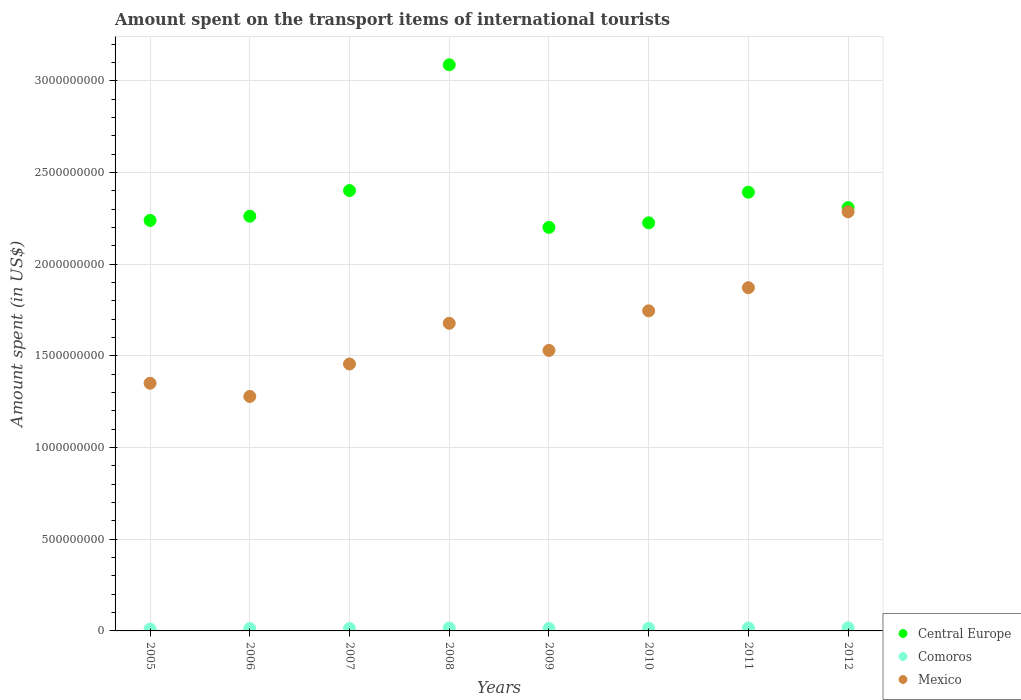How many different coloured dotlines are there?
Provide a succinct answer. 3. What is the amount spent on the transport items of international tourists in Central Europe in 2007?
Provide a succinct answer. 2.40e+09. Across all years, what is the maximum amount spent on the transport items of international tourists in Comoros?
Keep it short and to the point. 1.70e+07. Across all years, what is the minimum amount spent on the transport items of international tourists in Central Europe?
Your answer should be compact. 2.20e+09. In which year was the amount spent on the transport items of international tourists in Comoros minimum?
Keep it short and to the point. 2005. What is the total amount spent on the transport items of international tourists in Central Europe in the graph?
Make the answer very short. 1.91e+1. What is the difference between the amount spent on the transport items of international tourists in Mexico in 2005 and that in 2011?
Offer a very short reply. -5.21e+08. What is the difference between the amount spent on the transport items of international tourists in Mexico in 2010 and the amount spent on the transport items of international tourists in Central Europe in 2007?
Your response must be concise. -6.56e+08. What is the average amount spent on the transport items of international tourists in Central Europe per year?
Give a very brief answer. 2.39e+09. In the year 2012, what is the difference between the amount spent on the transport items of international tourists in Central Europe and amount spent on the transport items of international tourists in Mexico?
Offer a terse response. 2.30e+07. What is the ratio of the amount spent on the transport items of international tourists in Central Europe in 2009 to that in 2012?
Provide a succinct answer. 0.95. Is the amount spent on the transport items of international tourists in Central Europe in 2005 less than that in 2008?
Make the answer very short. Yes. Is the difference between the amount spent on the transport items of international tourists in Central Europe in 2007 and 2012 greater than the difference between the amount spent on the transport items of international tourists in Mexico in 2007 and 2012?
Your response must be concise. Yes. What is the difference between the highest and the second highest amount spent on the transport items of international tourists in Comoros?
Offer a very short reply. 1.00e+06. What is the difference between the highest and the lowest amount spent on the transport items of international tourists in Central Europe?
Provide a short and direct response. 8.87e+08. Is it the case that in every year, the sum of the amount spent on the transport items of international tourists in Mexico and amount spent on the transport items of international tourists in Comoros  is greater than the amount spent on the transport items of international tourists in Central Europe?
Provide a short and direct response. No. Is the amount spent on the transport items of international tourists in Comoros strictly greater than the amount spent on the transport items of international tourists in Central Europe over the years?
Your answer should be compact. No. How many dotlines are there?
Your response must be concise. 3. How many years are there in the graph?
Give a very brief answer. 8. Are the values on the major ticks of Y-axis written in scientific E-notation?
Give a very brief answer. No. Does the graph contain any zero values?
Offer a very short reply. No. Where does the legend appear in the graph?
Offer a terse response. Bottom right. How many legend labels are there?
Give a very brief answer. 3. What is the title of the graph?
Offer a very short reply. Amount spent on the transport items of international tourists. What is the label or title of the X-axis?
Your answer should be compact. Years. What is the label or title of the Y-axis?
Your answer should be compact. Amount spent (in US$). What is the Amount spent (in US$) in Central Europe in 2005?
Your answer should be compact. 2.24e+09. What is the Amount spent (in US$) of Mexico in 2005?
Your response must be concise. 1.35e+09. What is the Amount spent (in US$) in Central Europe in 2006?
Offer a terse response. 2.26e+09. What is the Amount spent (in US$) of Comoros in 2006?
Make the answer very short. 1.30e+07. What is the Amount spent (in US$) in Mexico in 2006?
Ensure brevity in your answer.  1.28e+09. What is the Amount spent (in US$) in Central Europe in 2007?
Your answer should be very brief. 2.40e+09. What is the Amount spent (in US$) of Comoros in 2007?
Offer a very short reply. 1.30e+07. What is the Amount spent (in US$) of Mexico in 2007?
Provide a succinct answer. 1.46e+09. What is the Amount spent (in US$) of Central Europe in 2008?
Ensure brevity in your answer.  3.09e+09. What is the Amount spent (in US$) of Comoros in 2008?
Make the answer very short. 1.60e+07. What is the Amount spent (in US$) in Mexico in 2008?
Ensure brevity in your answer.  1.68e+09. What is the Amount spent (in US$) in Central Europe in 2009?
Give a very brief answer. 2.20e+09. What is the Amount spent (in US$) in Comoros in 2009?
Offer a very short reply. 1.30e+07. What is the Amount spent (in US$) in Mexico in 2009?
Give a very brief answer. 1.53e+09. What is the Amount spent (in US$) in Central Europe in 2010?
Provide a short and direct response. 2.23e+09. What is the Amount spent (in US$) of Comoros in 2010?
Offer a terse response. 1.40e+07. What is the Amount spent (in US$) of Mexico in 2010?
Ensure brevity in your answer.  1.75e+09. What is the Amount spent (in US$) of Central Europe in 2011?
Provide a succinct answer. 2.39e+09. What is the Amount spent (in US$) of Comoros in 2011?
Your answer should be very brief. 1.60e+07. What is the Amount spent (in US$) in Mexico in 2011?
Give a very brief answer. 1.87e+09. What is the Amount spent (in US$) in Central Europe in 2012?
Ensure brevity in your answer.  2.31e+09. What is the Amount spent (in US$) in Comoros in 2012?
Your answer should be very brief. 1.70e+07. What is the Amount spent (in US$) in Mexico in 2012?
Your answer should be compact. 2.29e+09. Across all years, what is the maximum Amount spent (in US$) of Central Europe?
Your response must be concise. 3.09e+09. Across all years, what is the maximum Amount spent (in US$) of Comoros?
Your answer should be very brief. 1.70e+07. Across all years, what is the maximum Amount spent (in US$) in Mexico?
Provide a short and direct response. 2.29e+09. Across all years, what is the minimum Amount spent (in US$) of Central Europe?
Give a very brief answer. 2.20e+09. Across all years, what is the minimum Amount spent (in US$) of Mexico?
Offer a very short reply. 1.28e+09. What is the total Amount spent (in US$) of Central Europe in the graph?
Your answer should be very brief. 1.91e+1. What is the total Amount spent (in US$) of Comoros in the graph?
Make the answer very short. 1.12e+08. What is the total Amount spent (in US$) in Mexico in the graph?
Keep it short and to the point. 1.32e+1. What is the difference between the Amount spent (in US$) in Central Europe in 2005 and that in 2006?
Offer a terse response. -2.30e+07. What is the difference between the Amount spent (in US$) in Mexico in 2005 and that in 2006?
Your response must be concise. 7.20e+07. What is the difference between the Amount spent (in US$) in Central Europe in 2005 and that in 2007?
Provide a succinct answer. -1.63e+08. What is the difference between the Amount spent (in US$) of Mexico in 2005 and that in 2007?
Your answer should be compact. -1.05e+08. What is the difference between the Amount spent (in US$) of Central Europe in 2005 and that in 2008?
Provide a succinct answer. -8.49e+08. What is the difference between the Amount spent (in US$) of Comoros in 2005 and that in 2008?
Your response must be concise. -6.00e+06. What is the difference between the Amount spent (in US$) in Mexico in 2005 and that in 2008?
Give a very brief answer. -3.27e+08. What is the difference between the Amount spent (in US$) of Central Europe in 2005 and that in 2009?
Offer a very short reply. 3.80e+07. What is the difference between the Amount spent (in US$) in Comoros in 2005 and that in 2009?
Your answer should be very brief. -3.00e+06. What is the difference between the Amount spent (in US$) in Mexico in 2005 and that in 2009?
Offer a very short reply. -1.79e+08. What is the difference between the Amount spent (in US$) of Central Europe in 2005 and that in 2010?
Give a very brief answer. 1.30e+07. What is the difference between the Amount spent (in US$) in Mexico in 2005 and that in 2010?
Offer a very short reply. -3.95e+08. What is the difference between the Amount spent (in US$) in Central Europe in 2005 and that in 2011?
Your answer should be compact. -1.54e+08. What is the difference between the Amount spent (in US$) of Comoros in 2005 and that in 2011?
Ensure brevity in your answer.  -6.00e+06. What is the difference between the Amount spent (in US$) in Mexico in 2005 and that in 2011?
Give a very brief answer. -5.21e+08. What is the difference between the Amount spent (in US$) of Central Europe in 2005 and that in 2012?
Your response must be concise. -7.00e+07. What is the difference between the Amount spent (in US$) in Comoros in 2005 and that in 2012?
Give a very brief answer. -7.00e+06. What is the difference between the Amount spent (in US$) in Mexico in 2005 and that in 2012?
Provide a succinct answer. -9.35e+08. What is the difference between the Amount spent (in US$) of Central Europe in 2006 and that in 2007?
Your response must be concise. -1.40e+08. What is the difference between the Amount spent (in US$) of Mexico in 2006 and that in 2007?
Your response must be concise. -1.77e+08. What is the difference between the Amount spent (in US$) in Central Europe in 2006 and that in 2008?
Ensure brevity in your answer.  -8.26e+08. What is the difference between the Amount spent (in US$) of Comoros in 2006 and that in 2008?
Your answer should be very brief. -3.00e+06. What is the difference between the Amount spent (in US$) of Mexico in 2006 and that in 2008?
Provide a succinct answer. -3.99e+08. What is the difference between the Amount spent (in US$) of Central Europe in 2006 and that in 2009?
Your answer should be compact. 6.10e+07. What is the difference between the Amount spent (in US$) in Mexico in 2006 and that in 2009?
Offer a terse response. -2.51e+08. What is the difference between the Amount spent (in US$) of Central Europe in 2006 and that in 2010?
Provide a short and direct response. 3.60e+07. What is the difference between the Amount spent (in US$) in Comoros in 2006 and that in 2010?
Offer a terse response. -1.00e+06. What is the difference between the Amount spent (in US$) of Mexico in 2006 and that in 2010?
Keep it short and to the point. -4.67e+08. What is the difference between the Amount spent (in US$) in Central Europe in 2006 and that in 2011?
Provide a short and direct response. -1.31e+08. What is the difference between the Amount spent (in US$) in Mexico in 2006 and that in 2011?
Offer a terse response. -5.93e+08. What is the difference between the Amount spent (in US$) in Central Europe in 2006 and that in 2012?
Keep it short and to the point. -4.70e+07. What is the difference between the Amount spent (in US$) of Comoros in 2006 and that in 2012?
Your answer should be very brief. -4.00e+06. What is the difference between the Amount spent (in US$) in Mexico in 2006 and that in 2012?
Provide a short and direct response. -1.01e+09. What is the difference between the Amount spent (in US$) of Central Europe in 2007 and that in 2008?
Your answer should be very brief. -6.86e+08. What is the difference between the Amount spent (in US$) of Mexico in 2007 and that in 2008?
Give a very brief answer. -2.22e+08. What is the difference between the Amount spent (in US$) in Central Europe in 2007 and that in 2009?
Your answer should be very brief. 2.01e+08. What is the difference between the Amount spent (in US$) in Mexico in 2007 and that in 2009?
Ensure brevity in your answer.  -7.40e+07. What is the difference between the Amount spent (in US$) in Central Europe in 2007 and that in 2010?
Offer a very short reply. 1.76e+08. What is the difference between the Amount spent (in US$) in Comoros in 2007 and that in 2010?
Your answer should be compact. -1.00e+06. What is the difference between the Amount spent (in US$) of Mexico in 2007 and that in 2010?
Give a very brief answer. -2.90e+08. What is the difference between the Amount spent (in US$) in Central Europe in 2007 and that in 2011?
Your answer should be compact. 9.00e+06. What is the difference between the Amount spent (in US$) in Mexico in 2007 and that in 2011?
Your answer should be compact. -4.16e+08. What is the difference between the Amount spent (in US$) in Central Europe in 2007 and that in 2012?
Ensure brevity in your answer.  9.30e+07. What is the difference between the Amount spent (in US$) of Comoros in 2007 and that in 2012?
Your answer should be compact. -4.00e+06. What is the difference between the Amount spent (in US$) of Mexico in 2007 and that in 2012?
Offer a terse response. -8.30e+08. What is the difference between the Amount spent (in US$) of Central Europe in 2008 and that in 2009?
Your answer should be very brief. 8.87e+08. What is the difference between the Amount spent (in US$) in Mexico in 2008 and that in 2009?
Keep it short and to the point. 1.48e+08. What is the difference between the Amount spent (in US$) in Central Europe in 2008 and that in 2010?
Your response must be concise. 8.62e+08. What is the difference between the Amount spent (in US$) in Comoros in 2008 and that in 2010?
Offer a very short reply. 2.00e+06. What is the difference between the Amount spent (in US$) of Mexico in 2008 and that in 2010?
Make the answer very short. -6.80e+07. What is the difference between the Amount spent (in US$) of Central Europe in 2008 and that in 2011?
Keep it short and to the point. 6.95e+08. What is the difference between the Amount spent (in US$) of Comoros in 2008 and that in 2011?
Offer a very short reply. 0. What is the difference between the Amount spent (in US$) of Mexico in 2008 and that in 2011?
Give a very brief answer. -1.94e+08. What is the difference between the Amount spent (in US$) in Central Europe in 2008 and that in 2012?
Give a very brief answer. 7.79e+08. What is the difference between the Amount spent (in US$) of Comoros in 2008 and that in 2012?
Ensure brevity in your answer.  -1.00e+06. What is the difference between the Amount spent (in US$) in Mexico in 2008 and that in 2012?
Your answer should be very brief. -6.08e+08. What is the difference between the Amount spent (in US$) in Central Europe in 2009 and that in 2010?
Your answer should be very brief. -2.50e+07. What is the difference between the Amount spent (in US$) of Mexico in 2009 and that in 2010?
Your answer should be compact. -2.16e+08. What is the difference between the Amount spent (in US$) in Central Europe in 2009 and that in 2011?
Your answer should be compact. -1.92e+08. What is the difference between the Amount spent (in US$) in Mexico in 2009 and that in 2011?
Make the answer very short. -3.42e+08. What is the difference between the Amount spent (in US$) of Central Europe in 2009 and that in 2012?
Your answer should be very brief. -1.08e+08. What is the difference between the Amount spent (in US$) in Mexico in 2009 and that in 2012?
Offer a terse response. -7.56e+08. What is the difference between the Amount spent (in US$) of Central Europe in 2010 and that in 2011?
Make the answer very short. -1.67e+08. What is the difference between the Amount spent (in US$) of Mexico in 2010 and that in 2011?
Provide a succinct answer. -1.26e+08. What is the difference between the Amount spent (in US$) in Central Europe in 2010 and that in 2012?
Provide a succinct answer. -8.30e+07. What is the difference between the Amount spent (in US$) in Mexico in 2010 and that in 2012?
Offer a terse response. -5.40e+08. What is the difference between the Amount spent (in US$) of Central Europe in 2011 and that in 2012?
Provide a succinct answer. 8.40e+07. What is the difference between the Amount spent (in US$) in Mexico in 2011 and that in 2012?
Make the answer very short. -4.14e+08. What is the difference between the Amount spent (in US$) in Central Europe in 2005 and the Amount spent (in US$) in Comoros in 2006?
Provide a short and direct response. 2.23e+09. What is the difference between the Amount spent (in US$) in Central Europe in 2005 and the Amount spent (in US$) in Mexico in 2006?
Offer a very short reply. 9.60e+08. What is the difference between the Amount spent (in US$) of Comoros in 2005 and the Amount spent (in US$) of Mexico in 2006?
Your answer should be compact. -1.27e+09. What is the difference between the Amount spent (in US$) in Central Europe in 2005 and the Amount spent (in US$) in Comoros in 2007?
Give a very brief answer. 2.23e+09. What is the difference between the Amount spent (in US$) of Central Europe in 2005 and the Amount spent (in US$) of Mexico in 2007?
Your answer should be compact. 7.83e+08. What is the difference between the Amount spent (in US$) in Comoros in 2005 and the Amount spent (in US$) in Mexico in 2007?
Give a very brief answer. -1.45e+09. What is the difference between the Amount spent (in US$) in Central Europe in 2005 and the Amount spent (in US$) in Comoros in 2008?
Offer a very short reply. 2.22e+09. What is the difference between the Amount spent (in US$) in Central Europe in 2005 and the Amount spent (in US$) in Mexico in 2008?
Give a very brief answer. 5.61e+08. What is the difference between the Amount spent (in US$) of Comoros in 2005 and the Amount spent (in US$) of Mexico in 2008?
Your response must be concise. -1.67e+09. What is the difference between the Amount spent (in US$) of Central Europe in 2005 and the Amount spent (in US$) of Comoros in 2009?
Offer a very short reply. 2.23e+09. What is the difference between the Amount spent (in US$) of Central Europe in 2005 and the Amount spent (in US$) of Mexico in 2009?
Offer a terse response. 7.09e+08. What is the difference between the Amount spent (in US$) in Comoros in 2005 and the Amount spent (in US$) in Mexico in 2009?
Your answer should be compact. -1.52e+09. What is the difference between the Amount spent (in US$) in Central Europe in 2005 and the Amount spent (in US$) in Comoros in 2010?
Ensure brevity in your answer.  2.22e+09. What is the difference between the Amount spent (in US$) of Central Europe in 2005 and the Amount spent (in US$) of Mexico in 2010?
Your answer should be very brief. 4.93e+08. What is the difference between the Amount spent (in US$) of Comoros in 2005 and the Amount spent (in US$) of Mexico in 2010?
Your response must be concise. -1.74e+09. What is the difference between the Amount spent (in US$) in Central Europe in 2005 and the Amount spent (in US$) in Comoros in 2011?
Your answer should be compact. 2.22e+09. What is the difference between the Amount spent (in US$) in Central Europe in 2005 and the Amount spent (in US$) in Mexico in 2011?
Give a very brief answer. 3.67e+08. What is the difference between the Amount spent (in US$) in Comoros in 2005 and the Amount spent (in US$) in Mexico in 2011?
Provide a succinct answer. -1.86e+09. What is the difference between the Amount spent (in US$) in Central Europe in 2005 and the Amount spent (in US$) in Comoros in 2012?
Offer a very short reply. 2.22e+09. What is the difference between the Amount spent (in US$) in Central Europe in 2005 and the Amount spent (in US$) in Mexico in 2012?
Your answer should be very brief. -4.70e+07. What is the difference between the Amount spent (in US$) in Comoros in 2005 and the Amount spent (in US$) in Mexico in 2012?
Make the answer very short. -2.28e+09. What is the difference between the Amount spent (in US$) in Central Europe in 2006 and the Amount spent (in US$) in Comoros in 2007?
Give a very brief answer. 2.25e+09. What is the difference between the Amount spent (in US$) in Central Europe in 2006 and the Amount spent (in US$) in Mexico in 2007?
Your answer should be very brief. 8.06e+08. What is the difference between the Amount spent (in US$) in Comoros in 2006 and the Amount spent (in US$) in Mexico in 2007?
Your answer should be compact. -1.44e+09. What is the difference between the Amount spent (in US$) in Central Europe in 2006 and the Amount spent (in US$) in Comoros in 2008?
Keep it short and to the point. 2.25e+09. What is the difference between the Amount spent (in US$) in Central Europe in 2006 and the Amount spent (in US$) in Mexico in 2008?
Offer a very short reply. 5.84e+08. What is the difference between the Amount spent (in US$) in Comoros in 2006 and the Amount spent (in US$) in Mexico in 2008?
Give a very brief answer. -1.66e+09. What is the difference between the Amount spent (in US$) of Central Europe in 2006 and the Amount spent (in US$) of Comoros in 2009?
Provide a succinct answer. 2.25e+09. What is the difference between the Amount spent (in US$) of Central Europe in 2006 and the Amount spent (in US$) of Mexico in 2009?
Your response must be concise. 7.32e+08. What is the difference between the Amount spent (in US$) in Comoros in 2006 and the Amount spent (in US$) in Mexico in 2009?
Offer a terse response. -1.52e+09. What is the difference between the Amount spent (in US$) in Central Europe in 2006 and the Amount spent (in US$) in Comoros in 2010?
Provide a short and direct response. 2.25e+09. What is the difference between the Amount spent (in US$) of Central Europe in 2006 and the Amount spent (in US$) of Mexico in 2010?
Make the answer very short. 5.16e+08. What is the difference between the Amount spent (in US$) of Comoros in 2006 and the Amount spent (in US$) of Mexico in 2010?
Provide a succinct answer. -1.73e+09. What is the difference between the Amount spent (in US$) of Central Europe in 2006 and the Amount spent (in US$) of Comoros in 2011?
Ensure brevity in your answer.  2.25e+09. What is the difference between the Amount spent (in US$) in Central Europe in 2006 and the Amount spent (in US$) in Mexico in 2011?
Provide a short and direct response. 3.90e+08. What is the difference between the Amount spent (in US$) in Comoros in 2006 and the Amount spent (in US$) in Mexico in 2011?
Give a very brief answer. -1.86e+09. What is the difference between the Amount spent (in US$) of Central Europe in 2006 and the Amount spent (in US$) of Comoros in 2012?
Your answer should be compact. 2.24e+09. What is the difference between the Amount spent (in US$) of Central Europe in 2006 and the Amount spent (in US$) of Mexico in 2012?
Offer a very short reply. -2.40e+07. What is the difference between the Amount spent (in US$) in Comoros in 2006 and the Amount spent (in US$) in Mexico in 2012?
Offer a very short reply. -2.27e+09. What is the difference between the Amount spent (in US$) in Central Europe in 2007 and the Amount spent (in US$) in Comoros in 2008?
Keep it short and to the point. 2.39e+09. What is the difference between the Amount spent (in US$) of Central Europe in 2007 and the Amount spent (in US$) of Mexico in 2008?
Provide a short and direct response. 7.24e+08. What is the difference between the Amount spent (in US$) in Comoros in 2007 and the Amount spent (in US$) in Mexico in 2008?
Offer a very short reply. -1.66e+09. What is the difference between the Amount spent (in US$) of Central Europe in 2007 and the Amount spent (in US$) of Comoros in 2009?
Make the answer very short. 2.39e+09. What is the difference between the Amount spent (in US$) of Central Europe in 2007 and the Amount spent (in US$) of Mexico in 2009?
Provide a short and direct response. 8.72e+08. What is the difference between the Amount spent (in US$) in Comoros in 2007 and the Amount spent (in US$) in Mexico in 2009?
Your response must be concise. -1.52e+09. What is the difference between the Amount spent (in US$) in Central Europe in 2007 and the Amount spent (in US$) in Comoros in 2010?
Provide a succinct answer. 2.39e+09. What is the difference between the Amount spent (in US$) of Central Europe in 2007 and the Amount spent (in US$) of Mexico in 2010?
Ensure brevity in your answer.  6.56e+08. What is the difference between the Amount spent (in US$) in Comoros in 2007 and the Amount spent (in US$) in Mexico in 2010?
Ensure brevity in your answer.  -1.73e+09. What is the difference between the Amount spent (in US$) of Central Europe in 2007 and the Amount spent (in US$) of Comoros in 2011?
Provide a succinct answer. 2.39e+09. What is the difference between the Amount spent (in US$) of Central Europe in 2007 and the Amount spent (in US$) of Mexico in 2011?
Keep it short and to the point. 5.30e+08. What is the difference between the Amount spent (in US$) in Comoros in 2007 and the Amount spent (in US$) in Mexico in 2011?
Give a very brief answer. -1.86e+09. What is the difference between the Amount spent (in US$) of Central Europe in 2007 and the Amount spent (in US$) of Comoros in 2012?
Your answer should be very brief. 2.38e+09. What is the difference between the Amount spent (in US$) in Central Europe in 2007 and the Amount spent (in US$) in Mexico in 2012?
Ensure brevity in your answer.  1.16e+08. What is the difference between the Amount spent (in US$) of Comoros in 2007 and the Amount spent (in US$) of Mexico in 2012?
Your answer should be very brief. -2.27e+09. What is the difference between the Amount spent (in US$) in Central Europe in 2008 and the Amount spent (in US$) in Comoros in 2009?
Your answer should be compact. 3.08e+09. What is the difference between the Amount spent (in US$) of Central Europe in 2008 and the Amount spent (in US$) of Mexico in 2009?
Your answer should be compact. 1.56e+09. What is the difference between the Amount spent (in US$) of Comoros in 2008 and the Amount spent (in US$) of Mexico in 2009?
Give a very brief answer. -1.51e+09. What is the difference between the Amount spent (in US$) of Central Europe in 2008 and the Amount spent (in US$) of Comoros in 2010?
Offer a very short reply. 3.07e+09. What is the difference between the Amount spent (in US$) of Central Europe in 2008 and the Amount spent (in US$) of Mexico in 2010?
Ensure brevity in your answer.  1.34e+09. What is the difference between the Amount spent (in US$) in Comoros in 2008 and the Amount spent (in US$) in Mexico in 2010?
Your answer should be compact. -1.73e+09. What is the difference between the Amount spent (in US$) in Central Europe in 2008 and the Amount spent (in US$) in Comoros in 2011?
Your answer should be compact. 3.07e+09. What is the difference between the Amount spent (in US$) of Central Europe in 2008 and the Amount spent (in US$) of Mexico in 2011?
Provide a succinct answer. 1.22e+09. What is the difference between the Amount spent (in US$) in Comoros in 2008 and the Amount spent (in US$) in Mexico in 2011?
Keep it short and to the point. -1.86e+09. What is the difference between the Amount spent (in US$) of Central Europe in 2008 and the Amount spent (in US$) of Comoros in 2012?
Provide a succinct answer. 3.07e+09. What is the difference between the Amount spent (in US$) in Central Europe in 2008 and the Amount spent (in US$) in Mexico in 2012?
Give a very brief answer. 8.02e+08. What is the difference between the Amount spent (in US$) in Comoros in 2008 and the Amount spent (in US$) in Mexico in 2012?
Keep it short and to the point. -2.27e+09. What is the difference between the Amount spent (in US$) of Central Europe in 2009 and the Amount spent (in US$) of Comoros in 2010?
Keep it short and to the point. 2.19e+09. What is the difference between the Amount spent (in US$) in Central Europe in 2009 and the Amount spent (in US$) in Mexico in 2010?
Offer a very short reply. 4.55e+08. What is the difference between the Amount spent (in US$) in Comoros in 2009 and the Amount spent (in US$) in Mexico in 2010?
Ensure brevity in your answer.  -1.73e+09. What is the difference between the Amount spent (in US$) in Central Europe in 2009 and the Amount spent (in US$) in Comoros in 2011?
Your response must be concise. 2.18e+09. What is the difference between the Amount spent (in US$) in Central Europe in 2009 and the Amount spent (in US$) in Mexico in 2011?
Offer a terse response. 3.29e+08. What is the difference between the Amount spent (in US$) of Comoros in 2009 and the Amount spent (in US$) of Mexico in 2011?
Your answer should be compact. -1.86e+09. What is the difference between the Amount spent (in US$) of Central Europe in 2009 and the Amount spent (in US$) of Comoros in 2012?
Your response must be concise. 2.18e+09. What is the difference between the Amount spent (in US$) in Central Europe in 2009 and the Amount spent (in US$) in Mexico in 2012?
Your answer should be compact. -8.50e+07. What is the difference between the Amount spent (in US$) of Comoros in 2009 and the Amount spent (in US$) of Mexico in 2012?
Make the answer very short. -2.27e+09. What is the difference between the Amount spent (in US$) of Central Europe in 2010 and the Amount spent (in US$) of Comoros in 2011?
Give a very brief answer. 2.21e+09. What is the difference between the Amount spent (in US$) in Central Europe in 2010 and the Amount spent (in US$) in Mexico in 2011?
Give a very brief answer. 3.54e+08. What is the difference between the Amount spent (in US$) of Comoros in 2010 and the Amount spent (in US$) of Mexico in 2011?
Provide a short and direct response. -1.86e+09. What is the difference between the Amount spent (in US$) in Central Europe in 2010 and the Amount spent (in US$) in Comoros in 2012?
Ensure brevity in your answer.  2.21e+09. What is the difference between the Amount spent (in US$) in Central Europe in 2010 and the Amount spent (in US$) in Mexico in 2012?
Provide a succinct answer. -6.00e+07. What is the difference between the Amount spent (in US$) in Comoros in 2010 and the Amount spent (in US$) in Mexico in 2012?
Provide a short and direct response. -2.27e+09. What is the difference between the Amount spent (in US$) of Central Europe in 2011 and the Amount spent (in US$) of Comoros in 2012?
Your answer should be very brief. 2.38e+09. What is the difference between the Amount spent (in US$) of Central Europe in 2011 and the Amount spent (in US$) of Mexico in 2012?
Your answer should be very brief. 1.07e+08. What is the difference between the Amount spent (in US$) in Comoros in 2011 and the Amount spent (in US$) in Mexico in 2012?
Provide a short and direct response. -2.27e+09. What is the average Amount spent (in US$) of Central Europe per year?
Offer a very short reply. 2.39e+09. What is the average Amount spent (in US$) in Comoros per year?
Provide a short and direct response. 1.40e+07. What is the average Amount spent (in US$) in Mexico per year?
Provide a succinct answer. 1.65e+09. In the year 2005, what is the difference between the Amount spent (in US$) in Central Europe and Amount spent (in US$) in Comoros?
Make the answer very short. 2.23e+09. In the year 2005, what is the difference between the Amount spent (in US$) in Central Europe and Amount spent (in US$) in Mexico?
Give a very brief answer. 8.88e+08. In the year 2005, what is the difference between the Amount spent (in US$) of Comoros and Amount spent (in US$) of Mexico?
Your response must be concise. -1.34e+09. In the year 2006, what is the difference between the Amount spent (in US$) of Central Europe and Amount spent (in US$) of Comoros?
Keep it short and to the point. 2.25e+09. In the year 2006, what is the difference between the Amount spent (in US$) in Central Europe and Amount spent (in US$) in Mexico?
Offer a terse response. 9.83e+08. In the year 2006, what is the difference between the Amount spent (in US$) of Comoros and Amount spent (in US$) of Mexico?
Keep it short and to the point. -1.27e+09. In the year 2007, what is the difference between the Amount spent (in US$) of Central Europe and Amount spent (in US$) of Comoros?
Your response must be concise. 2.39e+09. In the year 2007, what is the difference between the Amount spent (in US$) in Central Europe and Amount spent (in US$) in Mexico?
Provide a short and direct response. 9.46e+08. In the year 2007, what is the difference between the Amount spent (in US$) of Comoros and Amount spent (in US$) of Mexico?
Make the answer very short. -1.44e+09. In the year 2008, what is the difference between the Amount spent (in US$) of Central Europe and Amount spent (in US$) of Comoros?
Ensure brevity in your answer.  3.07e+09. In the year 2008, what is the difference between the Amount spent (in US$) in Central Europe and Amount spent (in US$) in Mexico?
Make the answer very short. 1.41e+09. In the year 2008, what is the difference between the Amount spent (in US$) in Comoros and Amount spent (in US$) in Mexico?
Make the answer very short. -1.66e+09. In the year 2009, what is the difference between the Amount spent (in US$) in Central Europe and Amount spent (in US$) in Comoros?
Your response must be concise. 2.19e+09. In the year 2009, what is the difference between the Amount spent (in US$) in Central Europe and Amount spent (in US$) in Mexico?
Give a very brief answer. 6.71e+08. In the year 2009, what is the difference between the Amount spent (in US$) in Comoros and Amount spent (in US$) in Mexico?
Provide a short and direct response. -1.52e+09. In the year 2010, what is the difference between the Amount spent (in US$) in Central Europe and Amount spent (in US$) in Comoros?
Keep it short and to the point. 2.21e+09. In the year 2010, what is the difference between the Amount spent (in US$) in Central Europe and Amount spent (in US$) in Mexico?
Provide a succinct answer. 4.80e+08. In the year 2010, what is the difference between the Amount spent (in US$) of Comoros and Amount spent (in US$) of Mexico?
Your answer should be compact. -1.73e+09. In the year 2011, what is the difference between the Amount spent (in US$) in Central Europe and Amount spent (in US$) in Comoros?
Ensure brevity in your answer.  2.38e+09. In the year 2011, what is the difference between the Amount spent (in US$) of Central Europe and Amount spent (in US$) of Mexico?
Your answer should be very brief. 5.21e+08. In the year 2011, what is the difference between the Amount spent (in US$) of Comoros and Amount spent (in US$) of Mexico?
Make the answer very short. -1.86e+09. In the year 2012, what is the difference between the Amount spent (in US$) in Central Europe and Amount spent (in US$) in Comoros?
Your answer should be compact. 2.29e+09. In the year 2012, what is the difference between the Amount spent (in US$) in Central Europe and Amount spent (in US$) in Mexico?
Keep it short and to the point. 2.30e+07. In the year 2012, what is the difference between the Amount spent (in US$) in Comoros and Amount spent (in US$) in Mexico?
Make the answer very short. -2.27e+09. What is the ratio of the Amount spent (in US$) in Comoros in 2005 to that in 2006?
Offer a terse response. 0.77. What is the ratio of the Amount spent (in US$) of Mexico in 2005 to that in 2006?
Provide a succinct answer. 1.06. What is the ratio of the Amount spent (in US$) in Central Europe in 2005 to that in 2007?
Make the answer very short. 0.93. What is the ratio of the Amount spent (in US$) of Comoros in 2005 to that in 2007?
Make the answer very short. 0.77. What is the ratio of the Amount spent (in US$) of Mexico in 2005 to that in 2007?
Keep it short and to the point. 0.93. What is the ratio of the Amount spent (in US$) of Central Europe in 2005 to that in 2008?
Your answer should be very brief. 0.73. What is the ratio of the Amount spent (in US$) of Comoros in 2005 to that in 2008?
Provide a succinct answer. 0.62. What is the ratio of the Amount spent (in US$) of Mexico in 2005 to that in 2008?
Your response must be concise. 0.81. What is the ratio of the Amount spent (in US$) of Central Europe in 2005 to that in 2009?
Your answer should be compact. 1.02. What is the ratio of the Amount spent (in US$) in Comoros in 2005 to that in 2009?
Your response must be concise. 0.77. What is the ratio of the Amount spent (in US$) in Mexico in 2005 to that in 2009?
Ensure brevity in your answer.  0.88. What is the ratio of the Amount spent (in US$) in Central Europe in 2005 to that in 2010?
Offer a very short reply. 1.01. What is the ratio of the Amount spent (in US$) in Comoros in 2005 to that in 2010?
Offer a terse response. 0.71. What is the ratio of the Amount spent (in US$) in Mexico in 2005 to that in 2010?
Give a very brief answer. 0.77. What is the ratio of the Amount spent (in US$) of Central Europe in 2005 to that in 2011?
Provide a short and direct response. 0.94. What is the ratio of the Amount spent (in US$) of Mexico in 2005 to that in 2011?
Offer a terse response. 0.72. What is the ratio of the Amount spent (in US$) of Central Europe in 2005 to that in 2012?
Offer a terse response. 0.97. What is the ratio of the Amount spent (in US$) in Comoros in 2005 to that in 2012?
Provide a short and direct response. 0.59. What is the ratio of the Amount spent (in US$) of Mexico in 2005 to that in 2012?
Provide a short and direct response. 0.59. What is the ratio of the Amount spent (in US$) in Central Europe in 2006 to that in 2007?
Your response must be concise. 0.94. What is the ratio of the Amount spent (in US$) in Comoros in 2006 to that in 2007?
Give a very brief answer. 1. What is the ratio of the Amount spent (in US$) of Mexico in 2006 to that in 2007?
Ensure brevity in your answer.  0.88. What is the ratio of the Amount spent (in US$) of Central Europe in 2006 to that in 2008?
Give a very brief answer. 0.73. What is the ratio of the Amount spent (in US$) of Comoros in 2006 to that in 2008?
Offer a terse response. 0.81. What is the ratio of the Amount spent (in US$) of Mexico in 2006 to that in 2008?
Give a very brief answer. 0.76. What is the ratio of the Amount spent (in US$) in Central Europe in 2006 to that in 2009?
Your answer should be very brief. 1.03. What is the ratio of the Amount spent (in US$) of Mexico in 2006 to that in 2009?
Keep it short and to the point. 0.84. What is the ratio of the Amount spent (in US$) of Central Europe in 2006 to that in 2010?
Provide a succinct answer. 1.02. What is the ratio of the Amount spent (in US$) of Comoros in 2006 to that in 2010?
Ensure brevity in your answer.  0.93. What is the ratio of the Amount spent (in US$) in Mexico in 2006 to that in 2010?
Provide a short and direct response. 0.73. What is the ratio of the Amount spent (in US$) of Central Europe in 2006 to that in 2011?
Give a very brief answer. 0.95. What is the ratio of the Amount spent (in US$) in Comoros in 2006 to that in 2011?
Keep it short and to the point. 0.81. What is the ratio of the Amount spent (in US$) of Mexico in 2006 to that in 2011?
Your answer should be compact. 0.68. What is the ratio of the Amount spent (in US$) in Central Europe in 2006 to that in 2012?
Ensure brevity in your answer.  0.98. What is the ratio of the Amount spent (in US$) in Comoros in 2006 to that in 2012?
Provide a short and direct response. 0.76. What is the ratio of the Amount spent (in US$) of Mexico in 2006 to that in 2012?
Offer a very short reply. 0.56. What is the ratio of the Amount spent (in US$) of Comoros in 2007 to that in 2008?
Keep it short and to the point. 0.81. What is the ratio of the Amount spent (in US$) in Mexico in 2007 to that in 2008?
Your response must be concise. 0.87. What is the ratio of the Amount spent (in US$) of Central Europe in 2007 to that in 2009?
Your response must be concise. 1.09. What is the ratio of the Amount spent (in US$) in Comoros in 2007 to that in 2009?
Offer a terse response. 1. What is the ratio of the Amount spent (in US$) of Mexico in 2007 to that in 2009?
Provide a short and direct response. 0.95. What is the ratio of the Amount spent (in US$) in Central Europe in 2007 to that in 2010?
Your answer should be very brief. 1.08. What is the ratio of the Amount spent (in US$) in Comoros in 2007 to that in 2010?
Give a very brief answer. 0.93. What is the ratio of the Amount spent (in US$) in Mexico in 2007 to that in 2010?
Offer a very short reply. 0.83. What is the ratio of the Amount spent (in US$) of Comoros in 2007 to that in 2011?
Your answer should be compact. 0.81. What is the ratio of the Amount spent (in US$) in Mexico in 2007 to that in 2011?
Give a very brief answer. 0.78. What is the ratio of the Amount spent (in US$) in Central Europe in 2007 to that in 2012?
Make the answer very short. 1.04. What is the ratio of the Amount spent (in US$) in Comoros in 2007 to that in 2012?
Your answer should be compact. 0.76. What is the ratio of the Amount spent (in US$) of Mexico in 2007 to that in 2012?
Make the answer very short. 0.64. What is the ratio of the Amount spent (in US$) in Central Europe in 2008 to that in 2009?
Provide a succinct answer. 1.4. What is the ratio of the Amount spent (in US$) in Comoros in 2008 to that in 2009?
Make the answer very short. 1.23. What is the ratio of the Amount spent (in US$) of Mexico in 2008 to that in 2009?
Your response must be concise. 1.1. What is the ratio of the Amount spent (in US$) in Central Europe in 2008 to that in 2010?
Make the answer very short. 1.39. What is the ratio of the Amount spent (in US$) in Mexico in 2008 to that in 2010?
Ensure brevity in your answer.  0.96. What is the ratio of the Amount spent (in US$) of Central Europe in 2008 to that in 2011?
Provide a short and direct response. 1.29. What is the ratio of the Amount spent (in US$) of Mexico in 2008 to that in 2011?
Offer a terse response. 0.9. What is the ratio of the Amount spent (in US$) in Central Europe in 2008 to that in 2012?
Offer a very short reply. 1.34. What is the ratio of the Amount spent (in US$) of Comoros in 2008 to that in 2012?
Offer a very short reply. 0.94. What is the ratio of the Amount spent (in US$) in Mexico in 2008 to that in 2012?
Provide a succinct answer. 0.73. What is the ratio of the Amount spent (in US$) in Central Europe in 2009 to that in 2010?
Keep it short and to the point. 0.99. What is the ratio of the Amount spent (in US$) in Mexico in 2009 to that in 2010?
Provide a succinct answer. 0.88. What is the ratio of the Amount spent (in US$) of Central Europe in 2009 to that in 2011?
Your answer should be very brief. 0.92. What is the ratio of the Amount spent (in US$) in Comoros in 2009 to that in 2011?
Give a very brief answer. 0.81. What is the ratio of the Amount spent (in US$) in Mexico in 2009 to that in 2011?
Offer a very short reply. 0.82. What is the ratio of the Amount spent (in US$) in Central Europe in 2009 to that in 2012?
Provide a short and direct response. 0.95. What is the ratio of the Amount spent (in US$) in Comoros in 2009 to that in 2012?
Your answer should be very brief. 0.76. What is the ratio of the Amount spent (in US$) of Mexico in 2009 to that in 2012?
Your answer should be very brief. 0.67. What is the ratio of the Amount spent (in US$) in Central Europe in 2010 to that in 2011?
Provide a succinct answer. 0.93. What is the ratio of the Amount spent (in US$) in Mexico in 2010 to that in 2011?
Offer a terse response. 0.93. What is the ratio of the Amount spent (in US$) of Central Europe in 2010 to that in 2012?
Give a very brief answer. 0.96. What is the ratio of the Amount spent (in US$) of Comoros in 2010 to that in 2012?
Ensure brevity in your answer.  0.82. What is the ratio of the Amount spent (in US$) of Mexico in 2010 to that in 2012?
Make the answer very short. 0.76. What is the ratio of the Amount spent (in US$) in Central Europe in 2011 to that in 2012?
Your response must be concise. 1.04. What is the ratio of the Amount spent (in US$) of Comoros in 2011 to that in 2012?
Provide a succinct answer. 0.94. What is the ratio of the Amount spent (in US$) in Mexico in 2011 to that in 2012?
Give a very brief answer. 0.82. What is the difference between the highest and the second highest Amount spent (in US$) of Central Europe?
Offer a very short reply. 6.86e+08. What is the difference between the highest and the second highest Amount spent (in US$) of Mexico?
Your answer should be very brief. 4.14e+08. What is the difference between the highest and the lowest Amount spent (in US$) in Central Europe?
Your response must be concise. 8.87e+08. What is the difference between the highest and the lowest Amount spent (in US$) of Mexico?
Keep it short and to the point. 1.01e+09. 